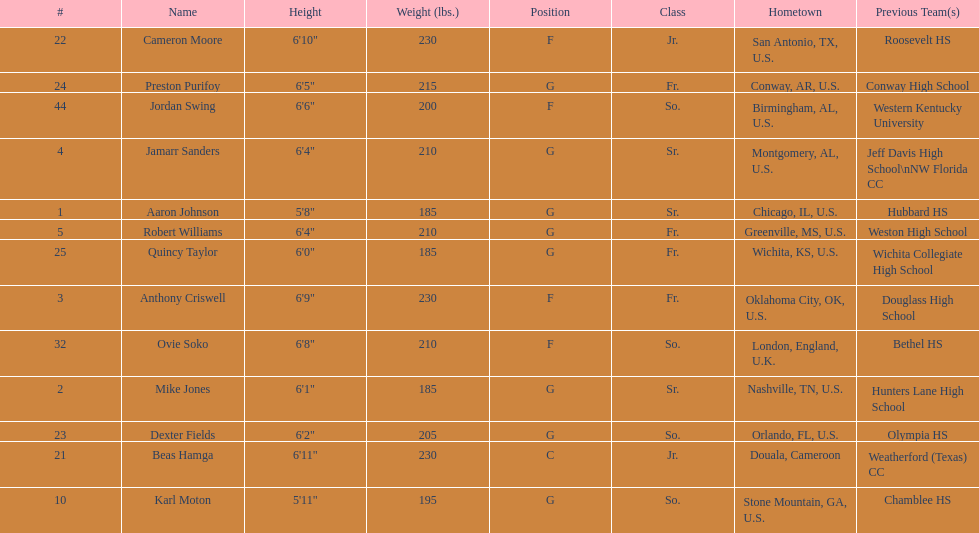Who is the tallest player on the team? Beas Hamga. 